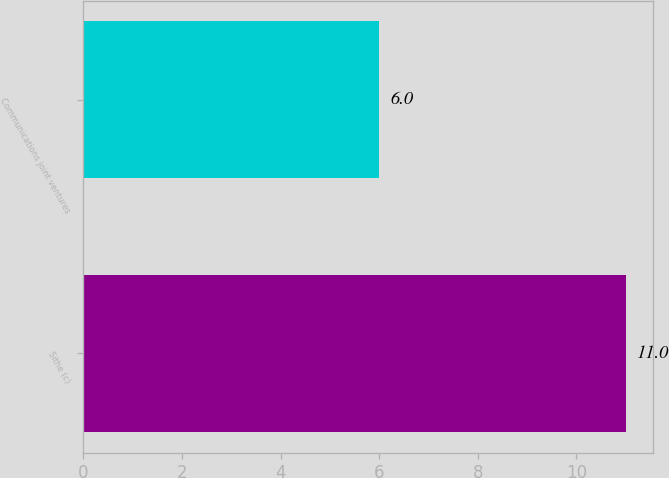Convert chart. <chart><loc_0><loc_0><loc_500><loc_500><bar_chart><fcel>Sithe (c)<fcel>Communications joint ventures<nl><fcel>11<fcel>6<nl></chart> 